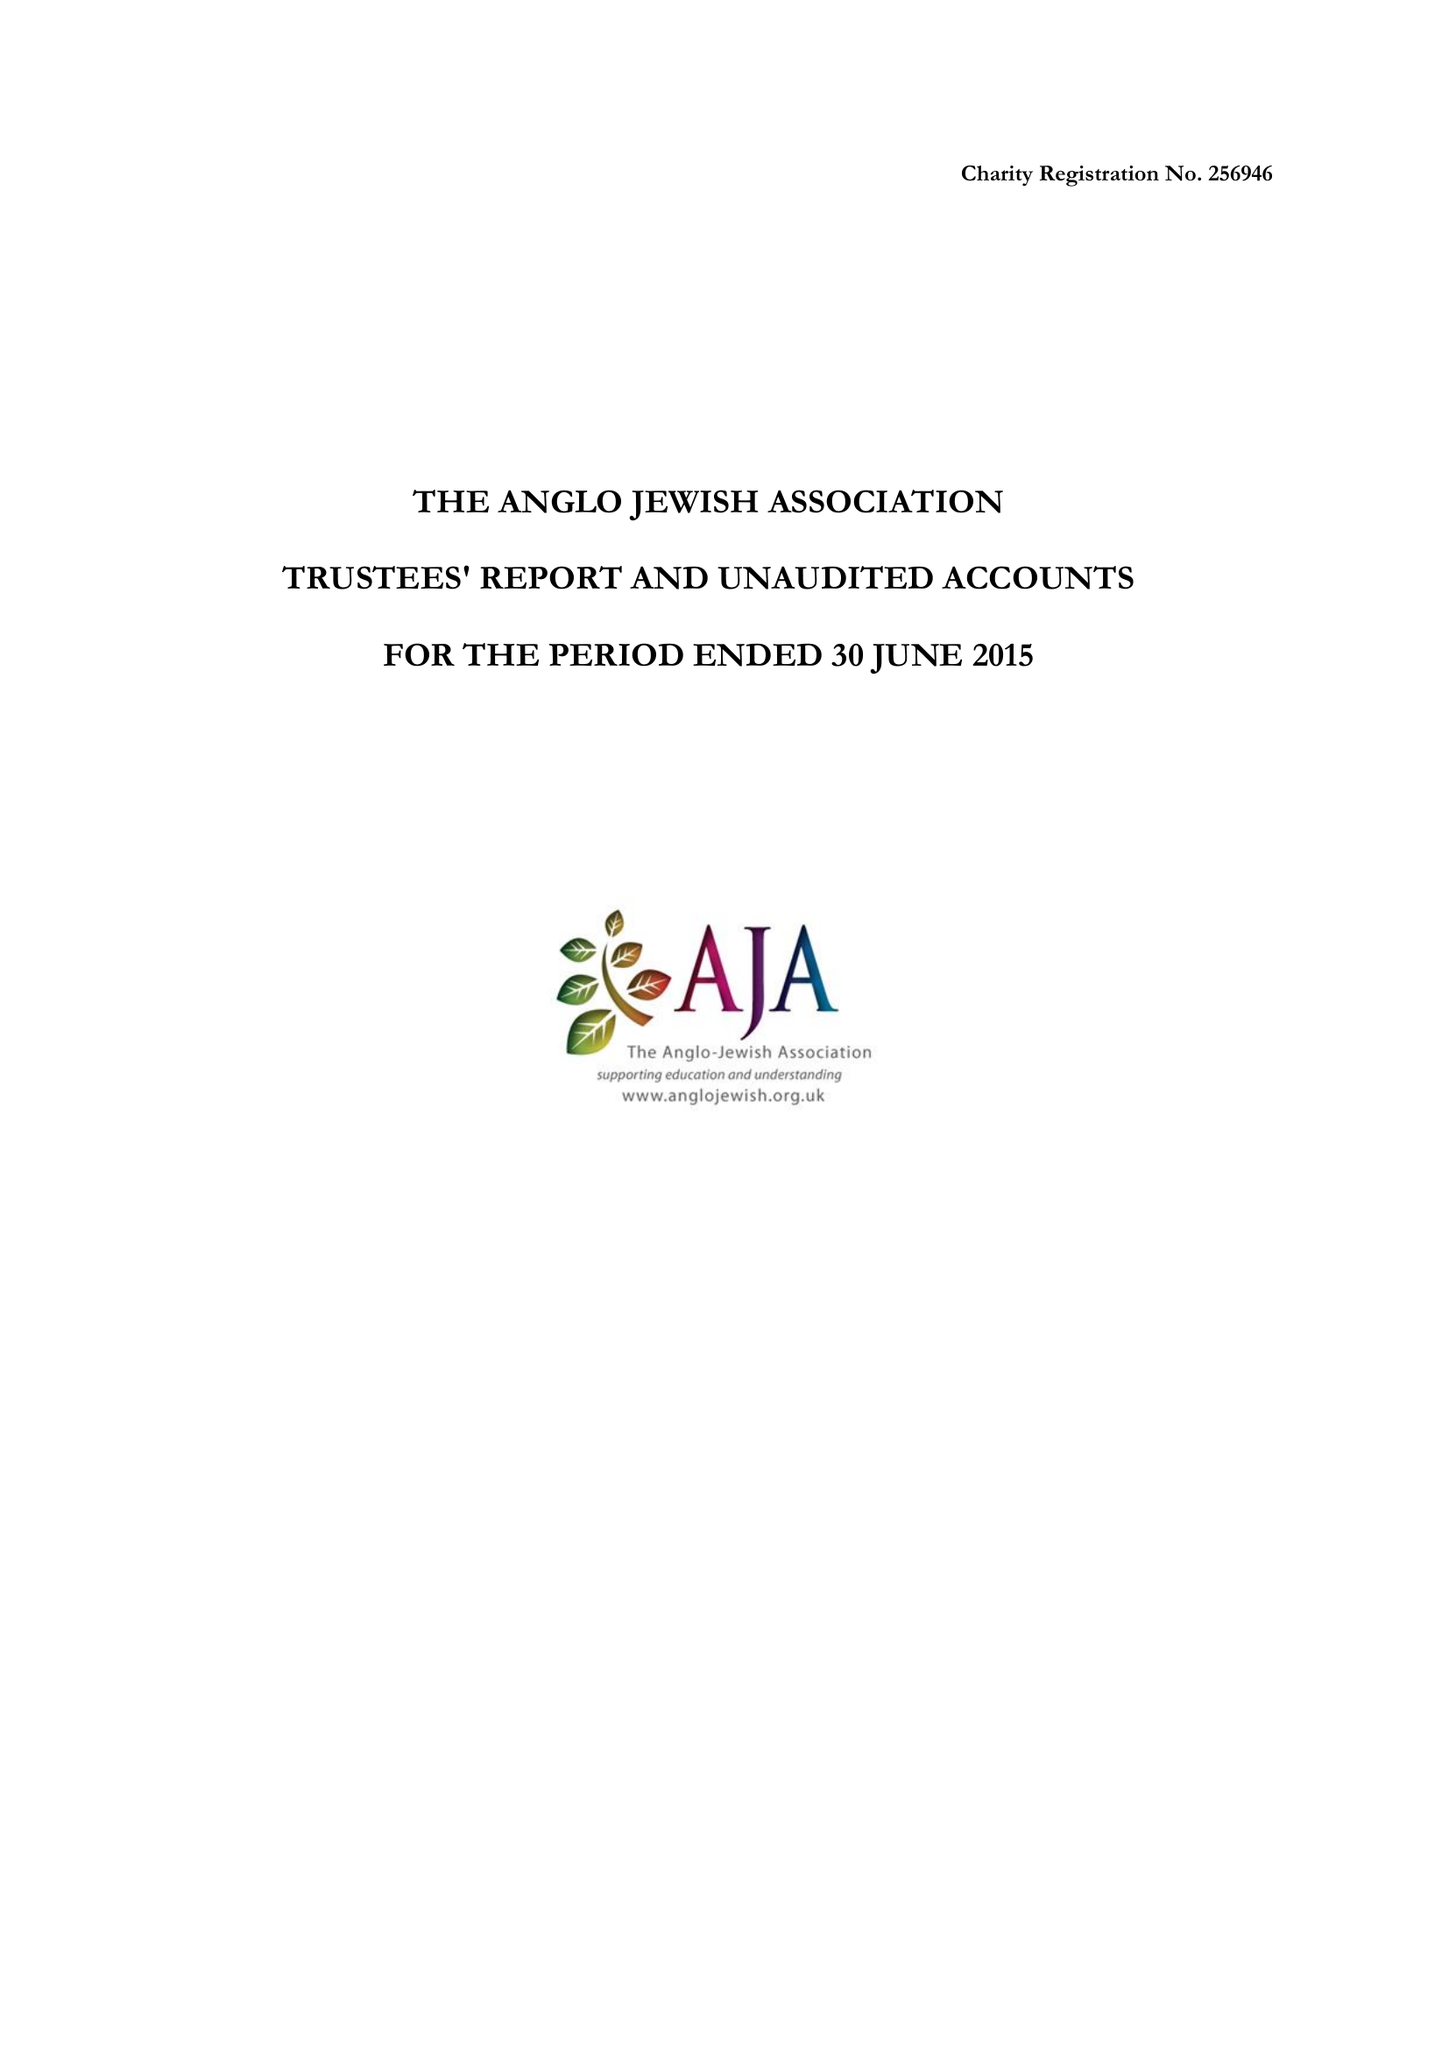What is the value for the charity_number?
Answer the question using a single word or phrase. 256946 